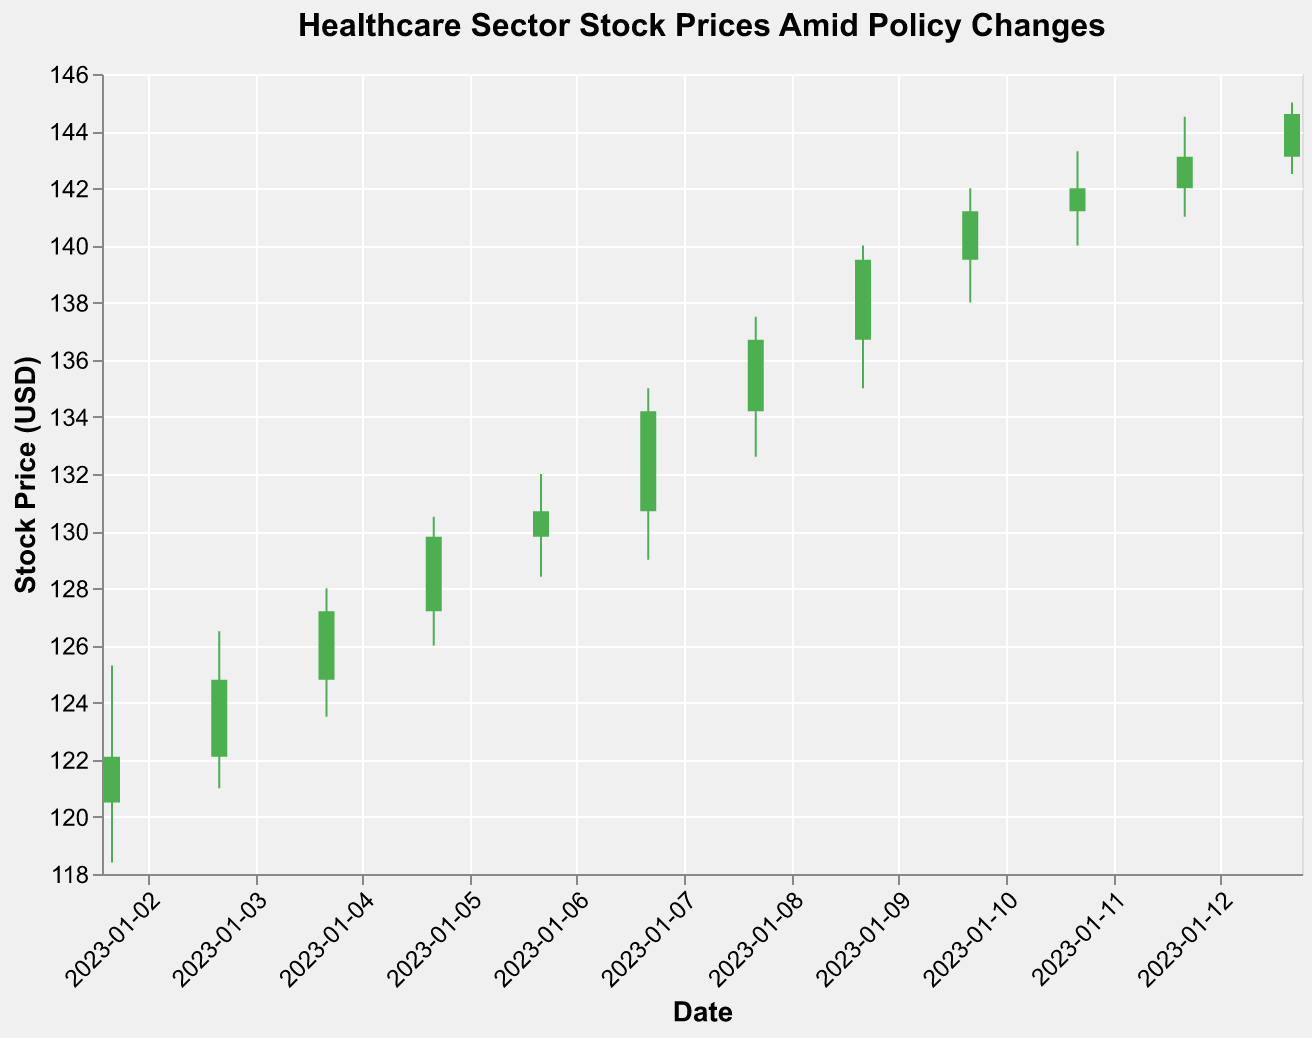What's the title of the figure? The title of the figure is displayed at the top. It reads, "Healthcare Sector Stock Prices Amid Policy Changes."
Answer: Healthcare Sector Stock Prices Amid Policy Changes How many days are represented in the figure? By counting the number of data points along the x-axis, you can see there are 12 days represented.
Answer: 12 On which date did the stock price have the highest closing value? The highest closing value can be identified by locating the highest point on the y-axis. The corresponding date is 2023-01-13.
Answer: 2023-01-13 What colors indicate an increase and a decrease in stock prices? The figure uses green to indicate an increase (close > open) and red to indicate a decrease (close < open).
Answer: Green for increase, Red for decrease What policy change corresponds to the highest trading volume? The highest trading volume can be identified by checking the volume for each date. It was on 2023-01-13 with the "New Insurance Mandate" policy change.
Answer: New Insurance Mandate What is the average closing price from 2023-01-02 to 2023-01-13? To find the average, sum all the closing prices and then divide by the number of data points: (122.1 + 124.8 + 127.2 + 129.8 + 130.7 + 134.2 + 136.7 + 139.5 + 141.2 + 142.0 + 143.1 + 144.6) / 12 = 135.35
Answer: 135.35 Between the dates 2023-01-02 and 2023-01-13, which policy change had the greatest impact on stock prices? Observing the changes in stock prices for different policies, the period on 2023-01-09 to 2023-01-11 under "Healthcare Policy Reversal" shows the largest daily increments in stock prices.
Answer: Healthcare Policy Reversal Which day saw the largest single-day increase in stock price? Calculate the difference between the closing and opening prices for each day. The day with the largest increase is 2023-01-07 (Close 134.2 - Open 130.7 = 3.5).
Answer: 2023-01-07 During the "Government Stability" period, how did the stock prices trend? Analyze the closing prices during the "Government Stability" period from 2023-01-07 to 2023-01-08. The prices increased from 134.2 to 136.7.
Answer: Increasing How did the trading volume change over the days? Observe the volume on each date: it generally trends upwards from 1,500,000 on 2023-01-02 to 2,300,000 on 2023-01-13, with some fluctuations in between.
Answer: Upwards trending 